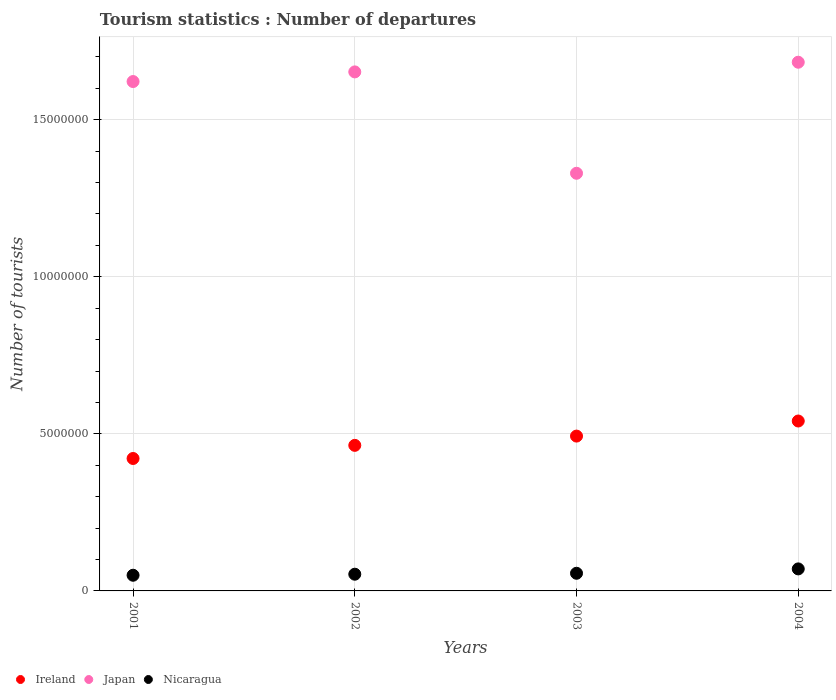Is the number of dotlines equal to the number of legend labels?
Provide a short and direct response. Yes. What is the number of tourist departures in Nicaragua in 2001?
Provide a short and direct response. 4.99e+05. Across all years, what is the maximum number of tourist departures in Japan?
Offer a terse response. 1.68e+07. Across all years, what is the minimum number of tourist departures in Japan?
Ensure brevity in your answer.  1.33e+07. In which year was the number of tourist departures in Japan maximum?
Your answer should be very brief. 2004. What is the total number of tourist departures in Japan in the graph?
Make the answer very short. 6.29e+07. What is the difference between the number of tourist departures in Nicaragua in 2003 and that in 2004?
Give a very brief answer. -1.39e+05. What is the difference between the number of tourist departures in Japan in 2004 and the number of tourist departures in Ireland in 2003?
Offer a terse response. 1.19e+07. What is the average number of tourist departures in Nicaragua per year?
Give a very brief answer. 5.74e+05. In the year 2003, what is the difference between the number of tourist departures in Ireland and number of tourist departures in Nicaragua?
Your response must be concise. 4.37e+06. In how many years, is the number of tourist departures in Japan greater than 1000000?
Your answer should be very brief. 4. What is the ratio of the number of tourist departures in Ireland in 2001 to that in 2004?
Ensure brevity in your answer.  0.78. Is the number of tourist departures in Nicaragua in 2001 less than that in 2004?
Ensure brevity in your answer.  Yes. What is the difference between the highest and the second highest number of tourist departures in Japan?
Ensure brevity in your answer.  3.08e+05. What is the difference between the highest and the lowest number of tourist departures in Ireland?
Your answer should be very brief. 1.19e+06. In how many years, is the number of tourist departures in Ireland greater than the average number of tourist departures in Ireland taken over all years?
Ensure brevity in your answer.  2. Does the number of tourist departures in Japan monotonically increase over the years?
Make the answer very short. No. Is the number of tourist departures in Nicaragua strictly less than the number of tourist departures in Japan over the years?
Make the answer very short. Yes. How many dotlines are there?
Ensure brevity in your answer.  3. How many years are there in the graph?
Keep it short and to the point. 4. What is the difference between two consecutive major ticks on the Y-axis?
Your answer should be compact. 5.00e+06. Are the values on the major ticks of Y-axis written in scientific E-notation?
Ensure brevity in your answer.  No. Does the graph contain any zero values?
Your response must be concise. No. Does the graph contain grids?
Your answer should be very brief. Yes. Where does the legend appear in the graph?
Your answer should be very brief. Bottom left. How are the legend labels stacked?
Keep it short and to the point. Horizontal. What is the title of the graph?
Offer a very short reply. Tourism statistics : Number of departures. What is the label or title of the X-axis?
Make the answer very short. Years. What is the label or title of the Y-axis?
Make the answer very short. Number of tourists. What is the Number of tourists in Ireland in 2001?
Give a very brief answer. 4.22e+06. What is the Number of tourists in Japan in 2001?
Offer a terse response. 1.62e+07. What is the Number of tourists in Nicaragua in 2001?
Offer a terse response. 4.99e+05. What is the Number of tourists in Ireland in 2002?
Ensure brevity in your answer.  4.63e+06. What is the Number of tourists in Japan in 2002?
Offer a terse response. 1.65e+07. What is the Number of tourists of Nicaragua in 2002?
Make the answer very short. 5.32e+05. What is the Number of tourists of Ireland in 2003?
Your answer should be very brief. 4.93e+06. What is the Number of tourists of Japan in 2003?
Offer a very short reply. 1.33e+07. What is the Number of tourists of Nicaragua in 2003?
Your response must be concise. 5.62e+05. What is the Number of tourists in Ireland in 2004?
Provide a short and direct response. 5.41e+06. What is the Number of tourists in Japan in 2004?
Keep it short and to the point. 1.68e+07. What is the Number of tourists in Nicaragua in 2004?
Give a very brief answer. 7.01e+05. Across all years, what is the maximum Number of tourists of Ireland?
Provide a succinct answer. 5.41e+06. Across all years, what is the maximum Number of tourists of Japan?
Keep it short and to the point. 1.68e+07. Across all years, what is the maximum Number of tourists in Nicaragua?
Your answer should be very brief. 7.01e+05. Across all years, what is the minimum Number of tourists of Ireland?
Keep it short and to the point. 4.22e+06. Across all years, what is the minimum Number of tourists of Japan?
Offer a very short reply. 1.33e+07. Across all years, what is the minimum Number of tourists in Nicaragua?
Your response must be concise. 4.99e+05. What is the total Number of tourists in Ireland in the graph?
Ensure brevity in your answer.  1.92e+07. What is the total Number of tourists in Japan in the graph?
Provide a succinct answer. 6.29e+07. What is the total Number of tourists of Nicaragua in the graph?
Give a very brief answer. 2.29e+06. What is the difference between the Number of tourists in Ireland in 2001 and that in 2002?
Your response must be concise. -4.18e+05. What is the difference between the Number of tourists in Japan in 2001 and that in 2002?
Offer a very short reply. -3.07e+05. What is the difference between the Number of tourists of Nicaragua in 2001 and that in 2002?
Keep it short and to the point. -3.30e+04. What is the difference between the Number of tourists of Ireland in 2001 and that in 2003?
Provide a short and direct response. -7.13e+05. What is the difference between the Number of tourists in Japan in 2001 and that in 2003?
Your answer should be very brief. 2.92e+06. What is the difference between the Number of tourists in Nicaragua in 2001 and that in 2003?
Your response must be concise. -6.30e+04. What is the difference between the Number of tourists in Ireland in 2001 and that in 2004?
Offer a very short reply. -1.19e+06. What is the difference between the Number of tourists of Japan in 2001 and that in 2004?
Ensure brevity in your answer.  -6.15e+05. What is the difference between the Number of tourists in Nicaragua in 2001 and that in 2004?
Give a very brief answer. -2.02e+05. What is the difference between the Number of tourists in Ireland in 2002 and that in 2003?
Offer a very short reply. -2.95e+05. What is the difference between the Number of tourists of Japan in 2002 and that in 2003?
Ensure brevity in your answer.  3.23e+06. What is the difference between the Number of tourists of Nicaragua in 2002 and that in 2003?
Your response must be concise. -3.00e+04. What is the difference between the Number of tourists in Ireland in 2002 and that in 2004?
Offer a very short reply. -7.75e+05. What is the difference between the Number of tourists of Japan in 2002 and that in 2004?
Your answer should be compact. -3.08e+05. What is the difference between the Number of tourists in Nicaragua in 2002 and that in 2004?
Offer a very short reply. -1.69e+05. What is the difference between the Number of tourists in Ireland in 2003 and that in 2004?
Provide a succinct answer. -4.80e+05. What is the difference between the Number of tourists in Japan in 2003 and that in 2004?
Offer a very short reply. -3.54e+06. What is the difference between the Number of tourists in Nicaragua in 2003 and that in 2004?
Your response must be concise. -1.39e+05. What is the difference between the Number of tourists of Ireland in 2001 and the Number of tourists of Japan in 2002?
Provide a short and direct response. -1.23e+07. What is the difference between the Number of tourists of Ireland in 2001 and the Number of tourists of Nicaragua in 2002?
Offer a very short reply. 3.68e+06. What is the difference between the Number of tourists of Japan in 2001 and the Number of tourists of Nicaragua in 2002?
Your response must be concise. 1.57e+07. What is the difference between the Number of tourists of Ireland in 2001 and the Number of tourists of Japan in 2003?
Offer a very short reply. -9.08e+06. What is the difference between the Number of tourists of Ireland in 2001 and the Number of tourists of Nicaragua in 2003?
Make the answer very short. 3.65e+06. What is the difference between the Number of tourists in Japan in 2001 and the Number of tourists in Nicaragua in 2003?
Provide a short and direct response. 1.57e+07. What is the difference between the Number of tourists of Ireland in 2001 and the Number of tourists of Japan in 2004?
Make the answer very short. -1.26e+07. What is the difference between the Number of tourists in Ireland in 2001 and the Number of tourists in Nicaragua in 2004?
Your response must be concise. 3.52e+06. What is the difference between the Number of tourists in Japan in 2001 and the Number of tourists in Nicaragua in 2004?
Offer a very short reply. 1.55e+07. What is the difference between the Number of tourists in Ireland in 2002 and the Number of tourists in Japan in 2003?
Make the answer very short. -8.66e+06. What is the difference between the Number of tourists of Ireland in 2002 and the Number of tourists of Nicaragua in 2003?
Keep it short and to the point. 4.07e+06. What is the difference between the Number of tourists in Japan in 2002 and the Number of tourists in Nicaragua in 2003?
Keep it short and to the point. 1.60e+07. What is the difference between the Number of tourists in Ireland in 2002 and the Number of tourists in Japan in 2004?
Ensure brevity in your answer.  -1.22e+07. What is the difference between the Number of tourists in Ireland in 2002 and the Number of tourists in Nicaragua in 2004?
Your answer should be compact. 3.93e+06. What is the difference between the Number of tourists of Japan in 2002 and the Number of tourists of Nicaragua in 2004?
Make the answer very short. 1.58e+07. What is the difference between the Number of tourists in Ireland in 2003 and the Number of tourists in Japan in 2004?
Keep it short and to the point. -1.19e+07. What is the difference between the Number of tourists of Ireland in 2003 and the Number of tourists of Nicaragua in 2004?
Ensure brevity in your answer.  4.23e+06. What is the difference between the Number of tourists in Japan in 2003 and the Number of tourists in Nicaragua in 2004?
Your answer should be compact. 1.26e+07. What is the average Number of tourists of Ireland per year?
Offer a very short reply. 4.80e+06. What is the average Number of tourists of Japan per year?
Your answer should be very brief. 1.57e+07. What is the average Number of tourists of Nicaragua per year?
Ensure brevity in your answer.  5.74e+05. In the year 2001, what is the difference between the Number of tourists in Ireland and Number of tourists in Japan?
Provide a succinct answer. -1.20e+07. In the year 2001, what is the difference between the Number of tourists of Ireland and Number of tourists of Nicaragua?
Ensure brevity in your answer.  3.72e+06. In the year 2001, what is the difference between the Number of tourists of Japan and Number of tourists of Nicaragua?
Your answer should be compact. 1.57e+07. In the year 2002, what is the difference between the Number of tourists of Ireland and Number of tourists of Japan?
Keep it short and to the point. -1.19e+07. In the year 2002, what is the difference between the Number of tourists of Ireland and Number of tourists of Nicaragua?
Provide a short and direct response. 4.10e+06. In the year 2002, what is the difference between the Number of tourists of Japan and Number of tourists of Nicaragua?
Your response must be concise. 1.60e+07. In the year 2003, what is the difference between the Number of tourists in Ireland and Number of tourists in Japan?
Provide a short and direct response. -8.37e+06. In the year 2003, what is the difference between the Number of tourists in Ireland and Number of tourists in Nicaragua?
Keep it short and to the point. 4.37e+06. In the year 2003, what is the difference between the Number of tourists in Japan and Number of tourists in Nicaragua?
Your answer should be compact. 1.27e+07. In the year 2004, what is the difference between the Number of tourists of Ireland and Number of tourists of Japan?
Your answer should be compact. -1.14e+07. In the year 2004, what is the difference between the Number of tourists in Ireland and Number of tourists in Nicaragua?
Offer a very short reply. 4.71e+06. In the year 2004, what is the difference between the Number of tourists in Japan and Number of tourists in Nicaragua?
Make the answer very short. 1.61e+07. What is the ratio of the Number of tourists of Ireland in 2001 to that in 2002?
Make the answer very short. 0.91. What is the ratio of the Number of tourists of Japan in 2001 to that in 2002?
Your answer should be very brief. 0.98. What is the ratio of the Number of tourists in Nicaragua in 2001 to that in 2002?
Provide a succinct answer. 0.94. What is the ratio of the Number of tourists of Ireland in 2001 to that in 2003?
Ensure brevity in your answer.  0.86. What is the ratio of the Number of tourists in Japan in 2001 to that in 2003?
Make the answer very short. 1.22. What is the ratio of the Number of tourists of Nicaragua in 2001 to that in 2003?
Offer a very short reply. 0.89. What is the ratio of the Number of tourists of Ireland in 2001 to that in 2004?
Your answer should be compact. 0.78. What is the ratio of the Number of tourists in Japan in 2001 to that in 2004?
Provide a short and direct response. 0.96. What is the ratio of the Number of tourists of Nicaragua in 2001 to that in 2004?
Offer a very short reply. 0.71. What is the ratio of the Number of tourists in Ireland in 2002 to that in 2003?
Provide a succinct answer. 0.94. What is the ratio of the Number of tourists of Japan in 2002 to that in 2003?
Your answer should be compact. 1.24. What is the ratio of the Number of tourists in Nicaragua in 2002 to that in 2003?
Your answer should be compact. 0.95. What is the ratio of the Number of tourists of Ireland in 2002 to that in 2004?
Keep it short and to the point. 0.86. What is the ratio of the Number of tourists in Japan in 2002 to that in 2004?
Make the answer very short. 0.98. What is the ratio of the Number of tourists in Nicaragua in 2002 to that in 2004?
Provide a short and direct response. 0.76. What is the ratio of the Number of tourists of Ireland in 2003 to that in 2004?
Give a very brief answer. 0.91. What is the ratio of the Number of tourists of Japan in 2003 to that in 2004?
Provide a succinct answer. 0.79. What is the ratio of the Number of tourists in Nicaragua in 2003 to that in 2004?
Give a very brief answer. 0.8. What is the difference between the highest and the second highest Number of tourists in Ireland?
Provide a succinct answer. 4.80e+05. What is the difference between the highest and the second highest Number of tourists in Japan?
Offer a terse response. 3.08e+05. What is the difference between the highest and the second highest Number of tourists of Nicaragua?
Keep it short and to the point. 1.39e+05. What is the difference between the highest and the lowest Number of tourists in Ireland?
Give a very brief answer. 1.19e+06. What is the difference between the highest and the lowest Number of tourists of Japan?
Ensure brevity in your answer.  3.54e+06. What is the difference between the highest and the lowest Number of tourists in Nicaragua?
Your answer should be compact. 2.02e+05. 